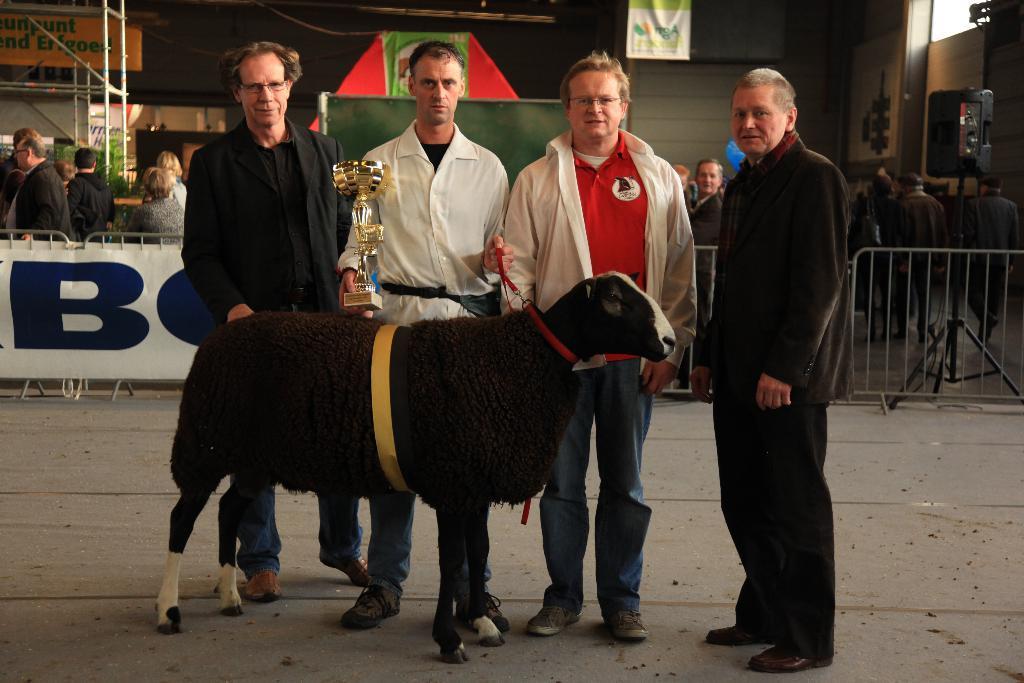Can you describe this image briefly? In this image I can see four people with different color dresses and there is an animal in-front of these people. I can see one person holding the trophy and the belt of an animal. In the background I can see the banner, railing, many people and the boards. I can also see the wall at the back. 